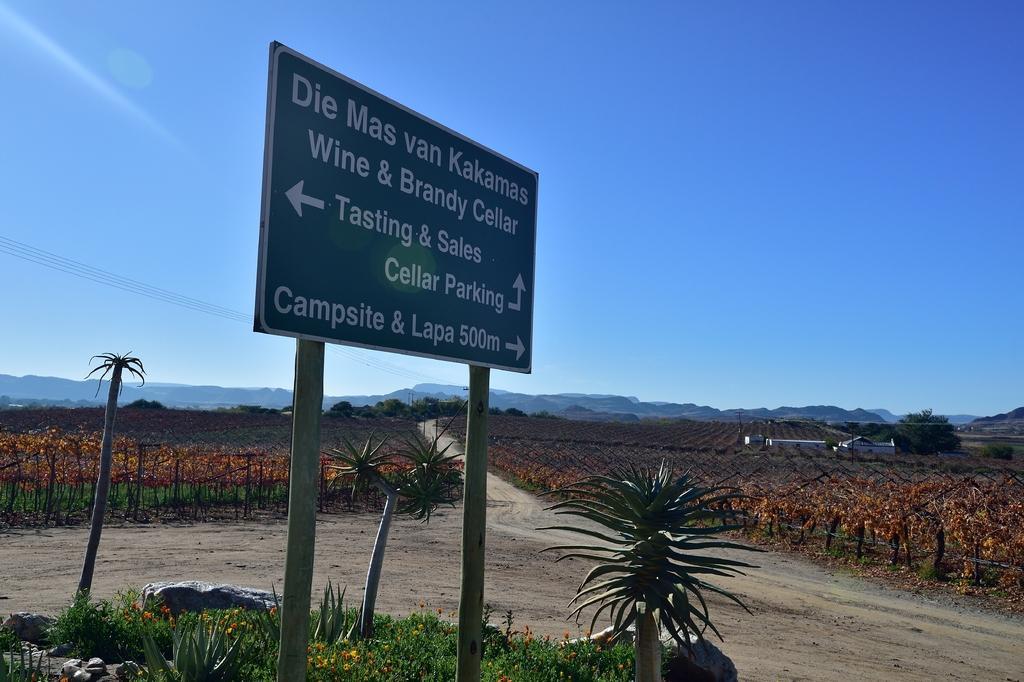In one or two sentences, can you explain what this image depicts? In this image there is a sign board, there are few plants, trees, cables, mountains, houses, agricultural land and the sky. 